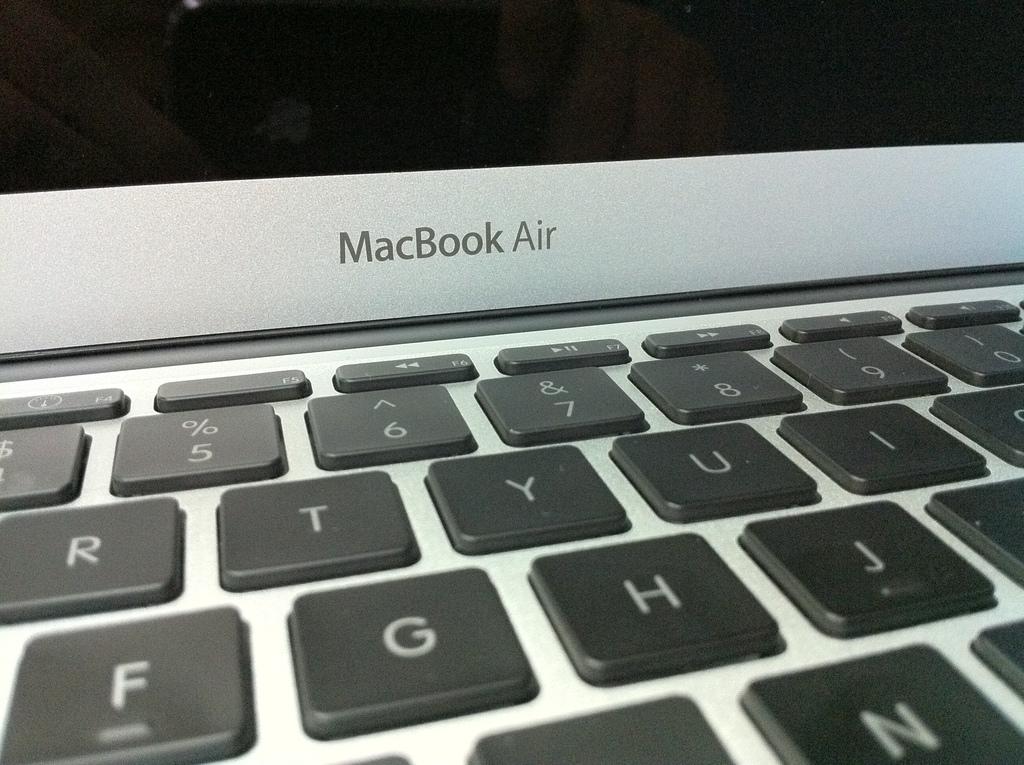What is the model name of this laptop?
Your response must be concise. Macbook air. What is the first letter shown in the second row?
Your answer should be very brief. R. 